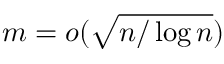<formula> <loc_0><loc_0><loc_500><loc_500>m = o ( \sqrt { n / \log n } )</formula> 